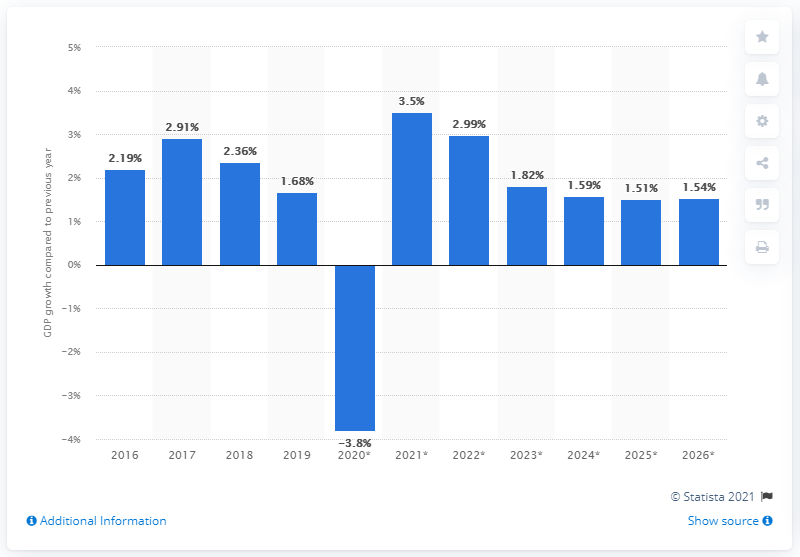Draw attention to some important aspects in this diagram. The real GDP in the Netherlands grew by 1.68% in 2019. 